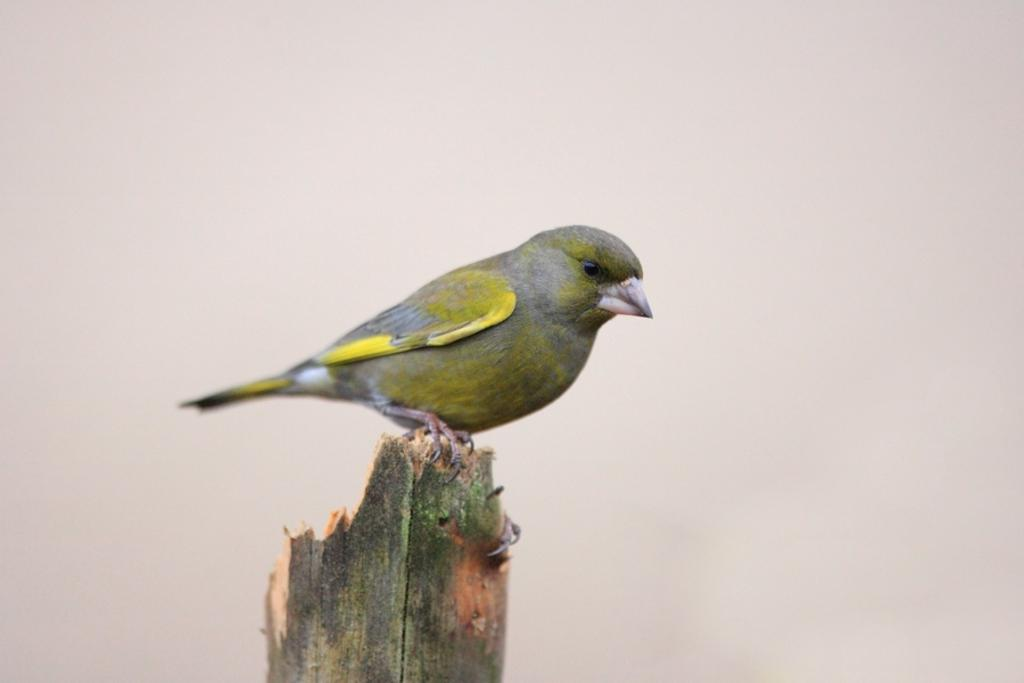What type of animal is in the image? There is a bird in the image. What colors can be seen on the bird? The bird has green and yellow colors. What is the bird standing on in the image? The bird is on a wooden stick. What color is the background of the image? The background of the image is white in color. Can you hear the bird laughing in the image? There is no sound in the image, so it is not possible to hear the bird laughing. 